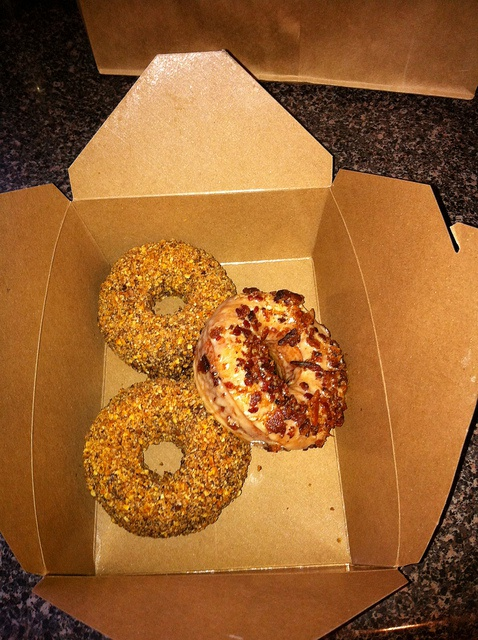Describe the objects in this image and their specific colors. I can see donut in black, brown, and orange tones, donut in black, orange, brown, and maroon tones, and donut in black, red, and orange tones in this image. 